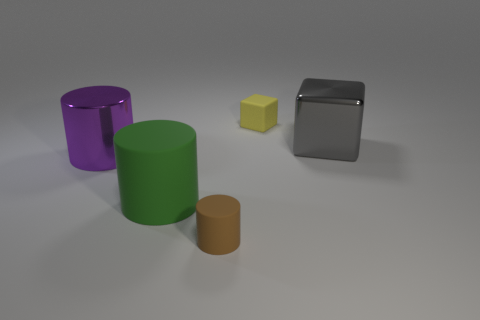What number of yellow objects are the same size as the gray thing?
Offer a very short reply. 0. Is the number of tiny things to the left of the yellow thing greater than the number of tiny blocks that are in front of the large purple object?
Offer a terse response. Yes. There is a rubber thing that is behind the big metal object on the left side of the tiny yellow rubber object; what is its color?
Provide a short and direct response. Yellow. Are the big purple thing and the tiny yellow block made of the same material?
Keep it short and to the point. No. Is there a small green thing of the same shape as the big purple object?
Offer a very short reply. No. There is a small rubber object that is to the left of the small yellow object; is it the same color as the small cube?
Make the answer very short. No. Does the cylinder that is right of the big green cylinder have the same size as the block that is on the right side of the small rubber cube?
Give a very brief answer. No. There is a cube that is made of the same material as the green cylinder; what size is it?
Provide a short and direct response. Small. What number of rubber objects are behind the tiny brown rubber thing and in front of the shiny block?
Your answer should be very brief. 1. How many things are yellow blocks or objects left of the brown object?
Your answer should be very brief. 3. 